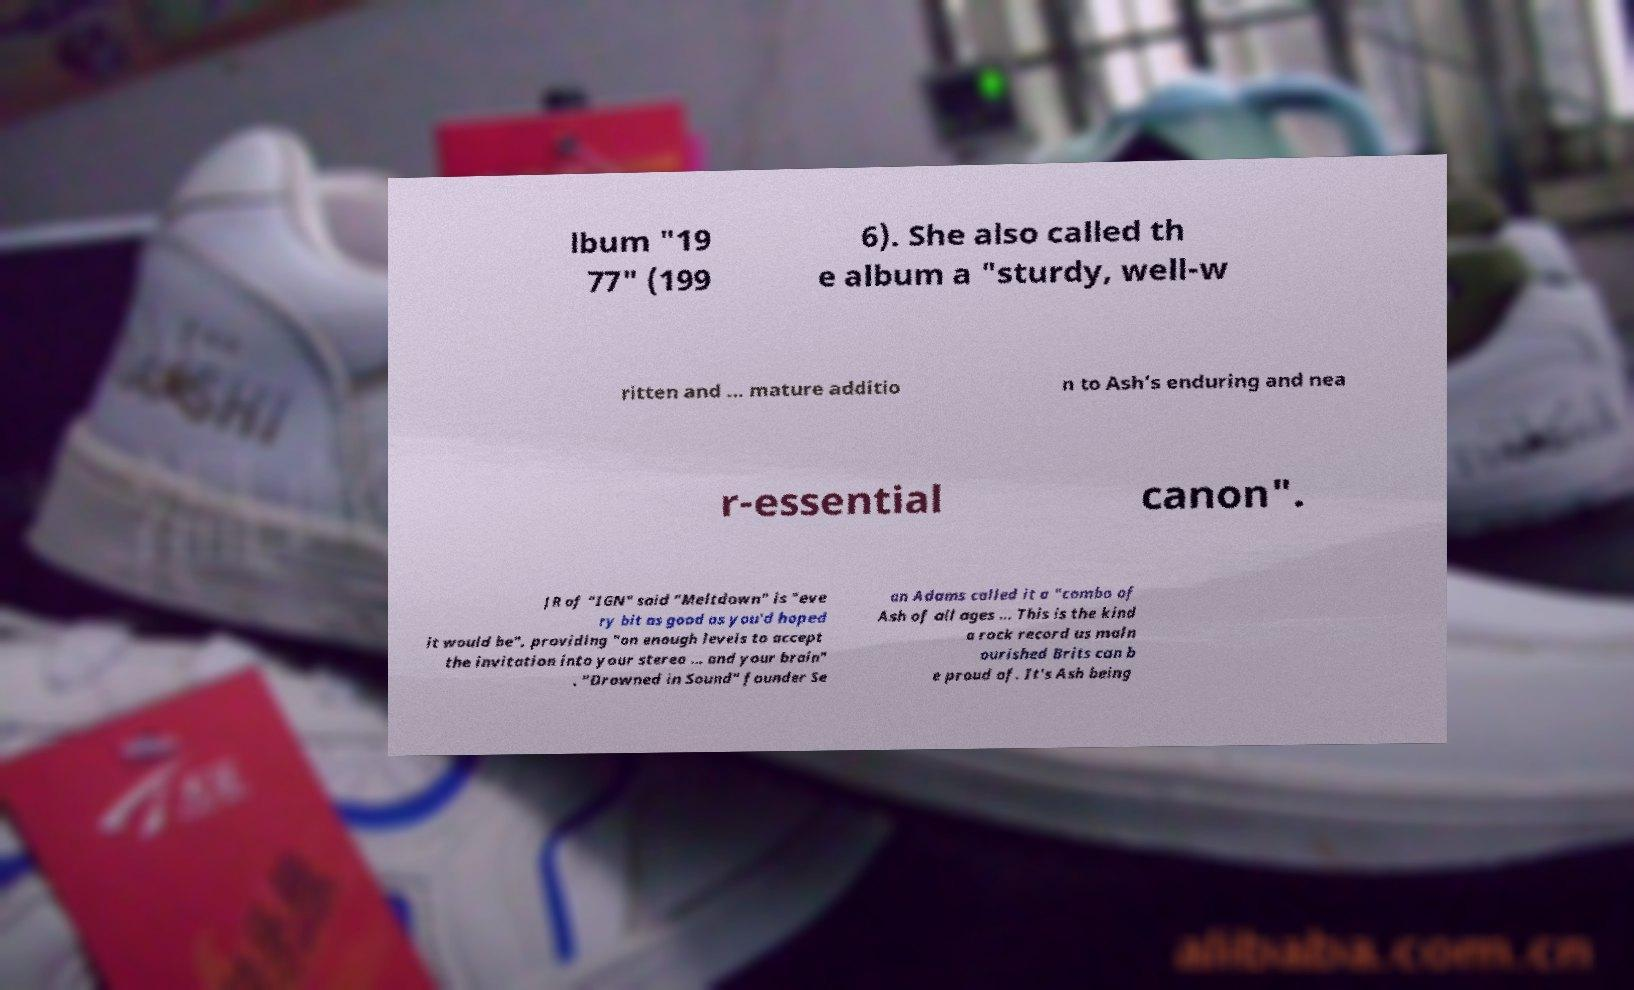Please identify and transcribe the text found in this image. lbum "19 77" (199 6). She also called th e album a "sturdy, well-w ritten and ... mature additio n to Ash’s enduring and nea r-essential canon". JR of "IGN" said "Meltdown" is "eve ry bit as good as you'd hoped it would be", providing "on enough levels to accept the invitation into your stereo ... and your brain" . "Drowned in Sound" founder Se an Adams called it a "combo of Ash of all ages ... This is the kind a rock record us maln ourished Brits can b e proud of. It's Ash being 